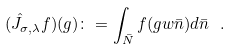<formula> <loc_0><loc_0><loc_500><loc_500>( \hat { J } _ { \sigma , \lambda } f ) ( g ) \colon = \int _ { \bar { N } } f ( g w \bar { n } ) d \bar { n } \ .</formula> 